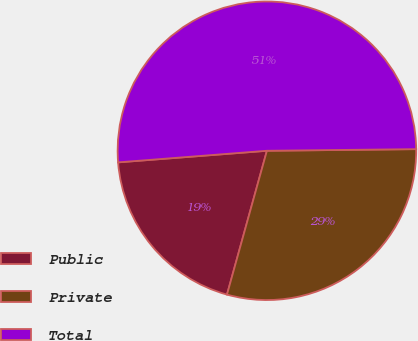<chart> <loc_0><loc_0><loc_500><loc_500><pie_chart><fcel>Public<fcel>Private<fcel>Total<nl><fcel>19.45%<fcel>29.48%<fcel>51.06%<nl></chart> 